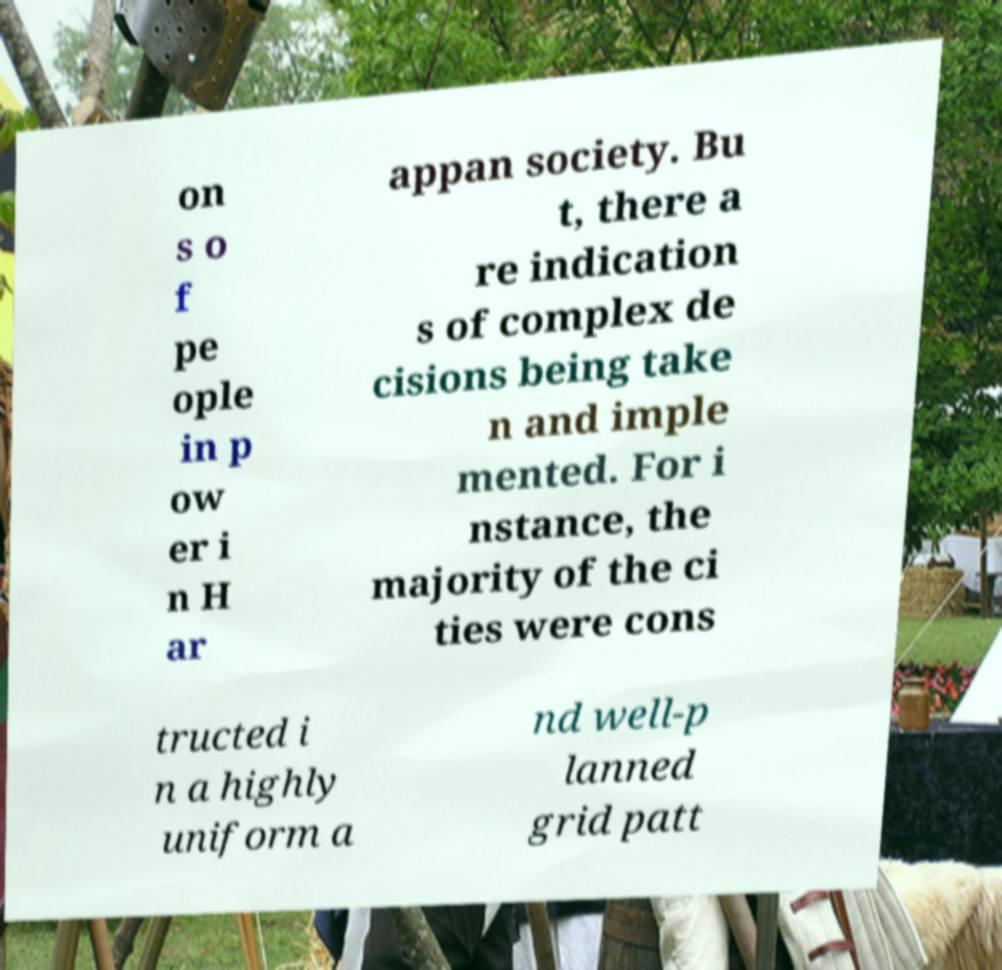Can you read and provide the text displayed in the image?This photo seems to have some interesting text. Can you extract and type it out for me? on s o f pe ople in p ow er i n H ar appan society. Bu t, there a re indication s of complex de cisions being take n and imple mented. For i nstance, the majority of the ci ties were cons tructed i n a highly uniform a nd well-p lanned grid patt 